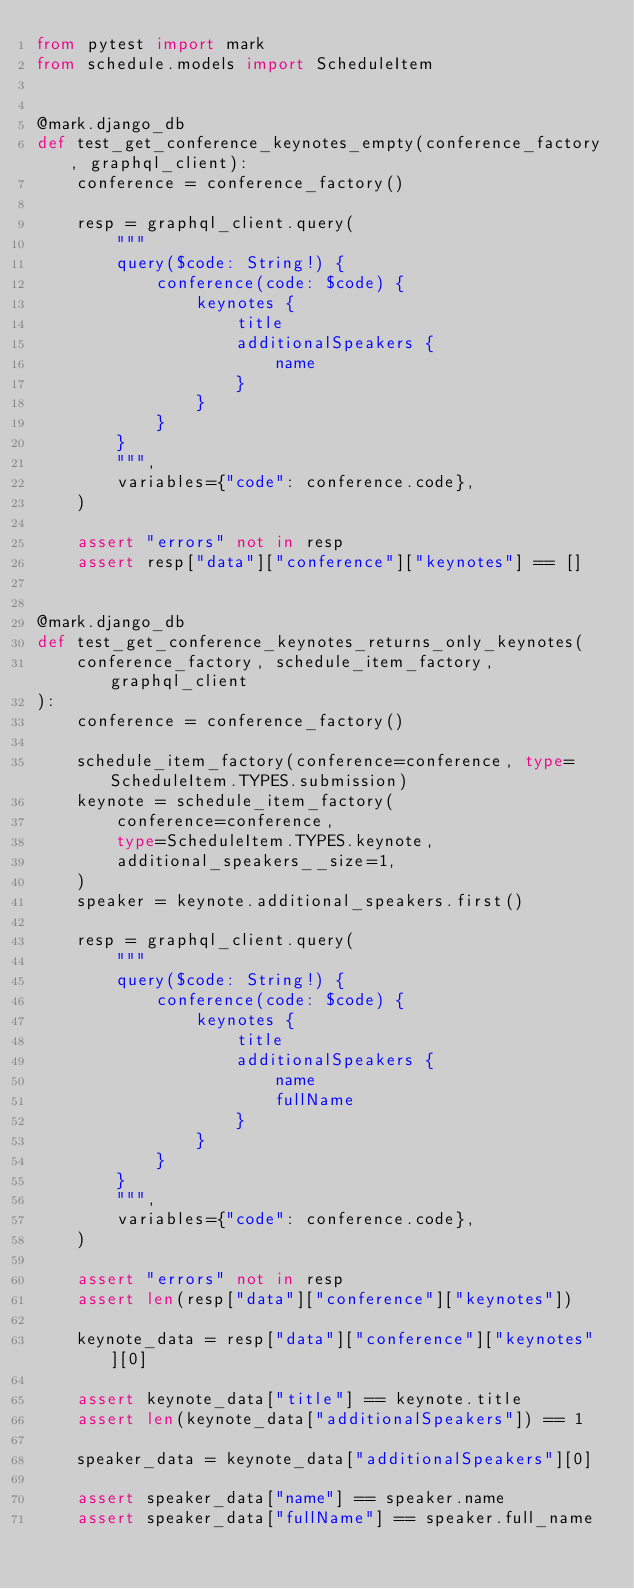Convert code to text. <code><loc_0><loc_0><loc_500><loc_500><_Python_>from pytest import mark
from schedule.models import ScheduleItem


@mark.django_db
def test_get_conference_keynotes_empty(conference_factory, graphql_client):
    conference = conference_factory()

    resp = graphql_client.query(
        """
        query($code: String!) {
            conference(code: $code) {
                keynotes {
                    title
                    additionalSpeakers {
                        name
                    }
                }
            }
        }
        """,
        variables={"code": conference.code},
    )

    assert "errors" not in resp
    assert resp["data"]["conference"]["keynotes"] == []


@mark.django_db
def test_get_conference_keynotes_returns_only_keynotes(
    conference_factory, schedule_item_factory, graphql_client
):
    conference = conference_factory()

    schedule_item_factory(conference=conference, type=ScheduleItem.TYPES.submission)
    keynote = schedule_item_factory(
        conference=conference,
        type=ScheduleItem.TYPES.keynote,
        additional_speakers__size=1,
    )
    speaker = keynote.additional_speakers.first()

    resp = graphql_client.query(
        """
        query($code: String!) {
            conference(code: $code) {
                keynotes {
                    title
                    additionalSpeakers {
                        name
                        fullName
                    }
                }
            }
        }
        """,
        variables={"code": conference.code},
    )

    assert "errors" not in resp
    assert len(resp["data"]["conference"]["keynotes"])

    keynote_data = resp["data"]["conference"]["keynotes"][0]

    assert keynote_data["title"] == keynote.title
    assert len(keynote_data["additionalSpeakers"]) == 1

    speaker_data = keynote_data["additionalSpeakers"][0]

    assert speaker_data["name"] == speaker.name
    assert speaker_data["fullName"] == speaker.full_name
</code> 